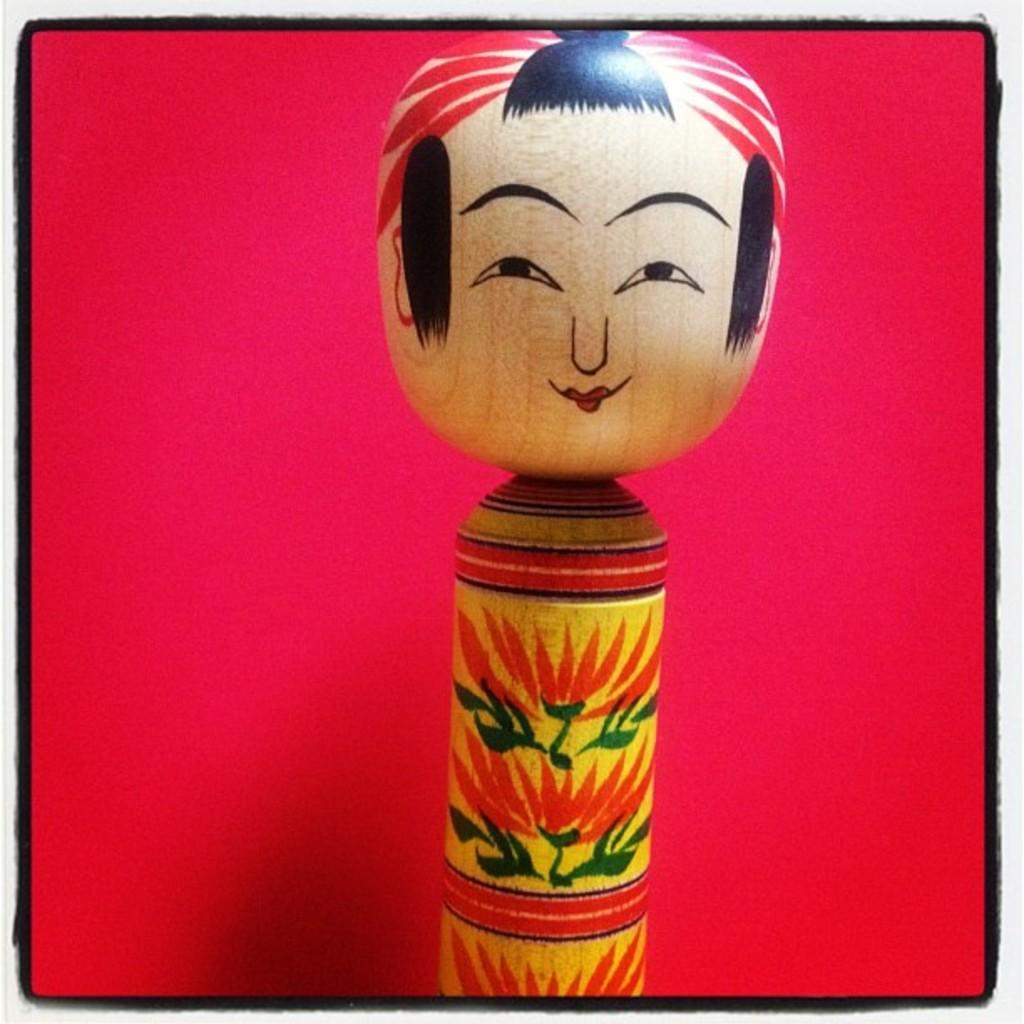What is the main subject of the image? There is a puppet in the image. What material is the puppet made of? The puppet is made up of wood. What color is the background of the image? The background of the image is red. What letter is the puppet holding in the image? There is no letter present in the image; it only features a wooden puppet. What emotion does the puppet display in the image? The image does not convey any specific emotion, so it cannot be determined from the picture. 